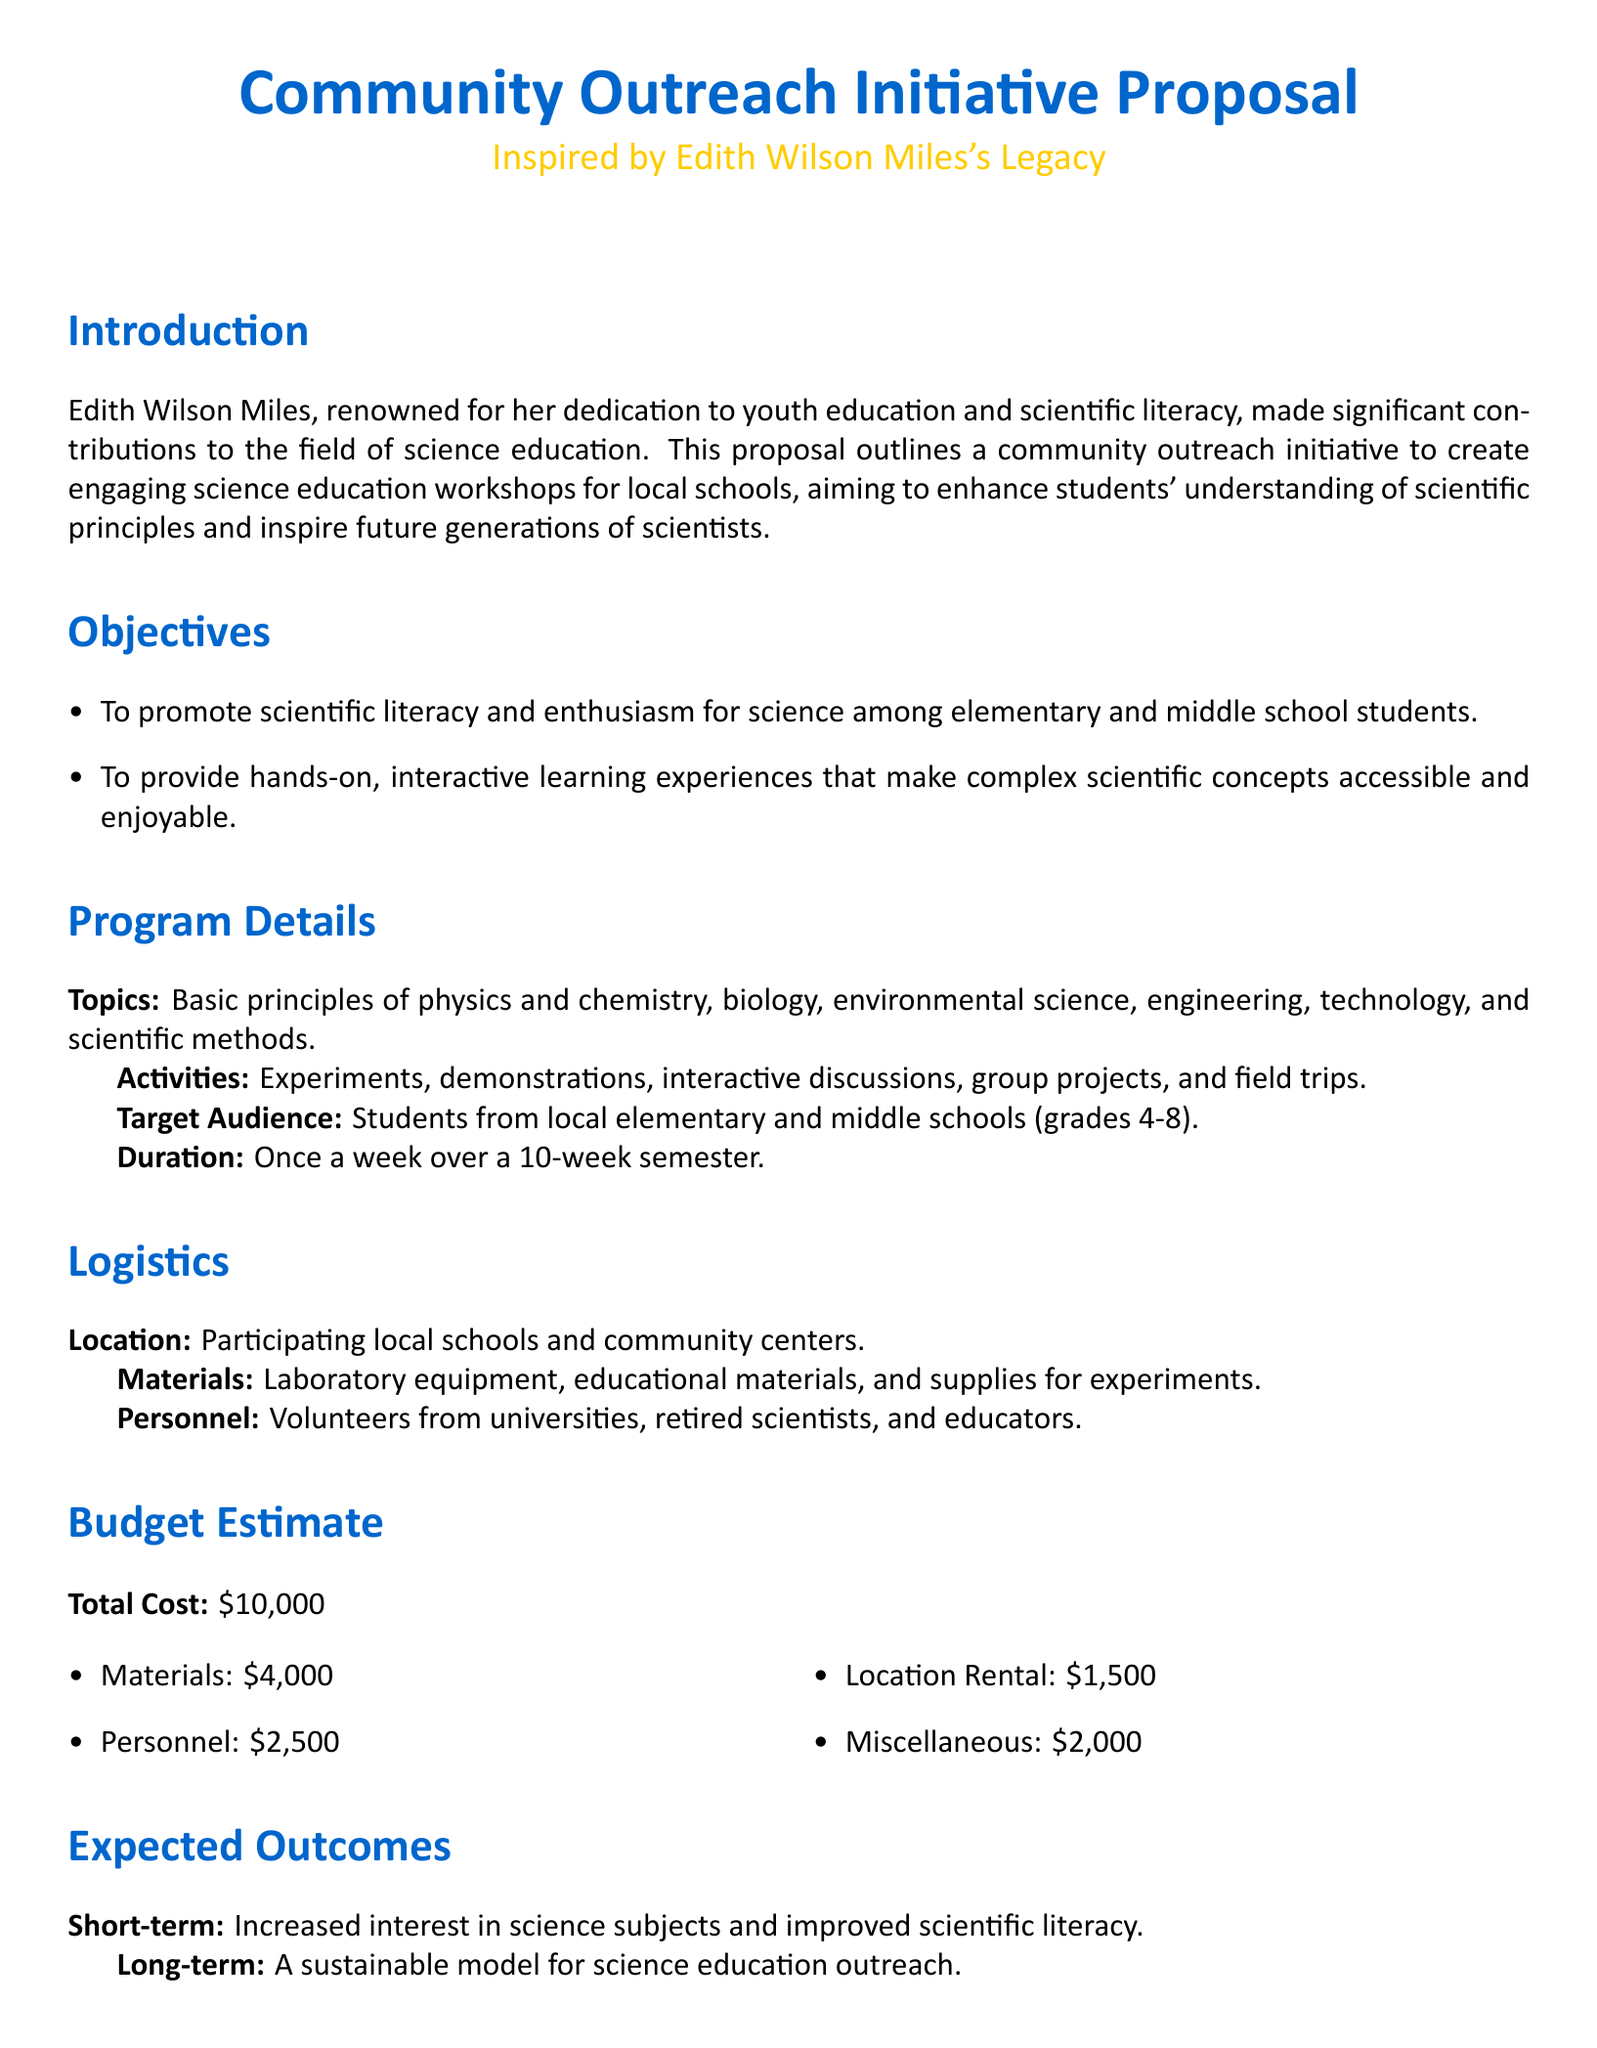what is the total cost of the initiative? The total cost is explicitly stated in the budget estimate section of the document.
Answer: $10,000 who is the target audience for the workshops? The document specifies the audience as students from local elementary and middle schools, particularly those in grades 4-8.
Answer: Students from local elementary and middle schools (grades 4-8) how many weeks will the workshops be conducted? The duration of the workshops is mentioned in the program details section of the document.
Answer: 10 weeks what type of activities will be included in the workshops? The document lists various activities that will be incorporated into the workshops under the program details section.
Answer: Experiments, demonstrations, interactive discussions, group projects, and field trips what is one of the expected short-term outcomes? The document outlines short-term outcomes within the expected outcomes section.
Answer: Increased interest in science subjects who are involved as personnel for the program? The document indicates the personnel involved in the program within the logistics section.
Answer: Volunteers from universities, retired scientists, and educators what is the location of the workshops? The document specifies the locations for the workshops in the logistics section.
Answer: Participating local schools and community centers what is the purpose of the initiative? The introduction section describes the aim of this community outreach initiative in relation to scientific literacy and education.
Answer: To create engaging science education workshops for local schools 